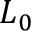<formula> <loc_0><loc_0><loc_500><loc_500>L _ { 0 }</formula> 